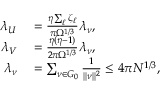<formula> <loc_0><loc_0><loc_500><loc_500>\begin{array} { r l } { \lambda _ { U } } & = \frac { \eta \sum _ { \ell } \zeta _ { \ell } } { \pi \Omega ^ { 1 / 3 } } \lambda _ { \nu } , } \\ { \lambda _ { V } } & = \frac { \eta ( \eta - 1 ) } { 2 \pi \Omega ^ { 1 / 3 } } \lambda _ { \nu } , } \\ { \lambda _ { \nu } } & = \sum _ { \nu \in G _ { 0 } } \frac { 1 } \| \nu \| ^ { 2 } } \leq 4 \pi N ^ { 1 / 3 } , } \end{array}</formula> 